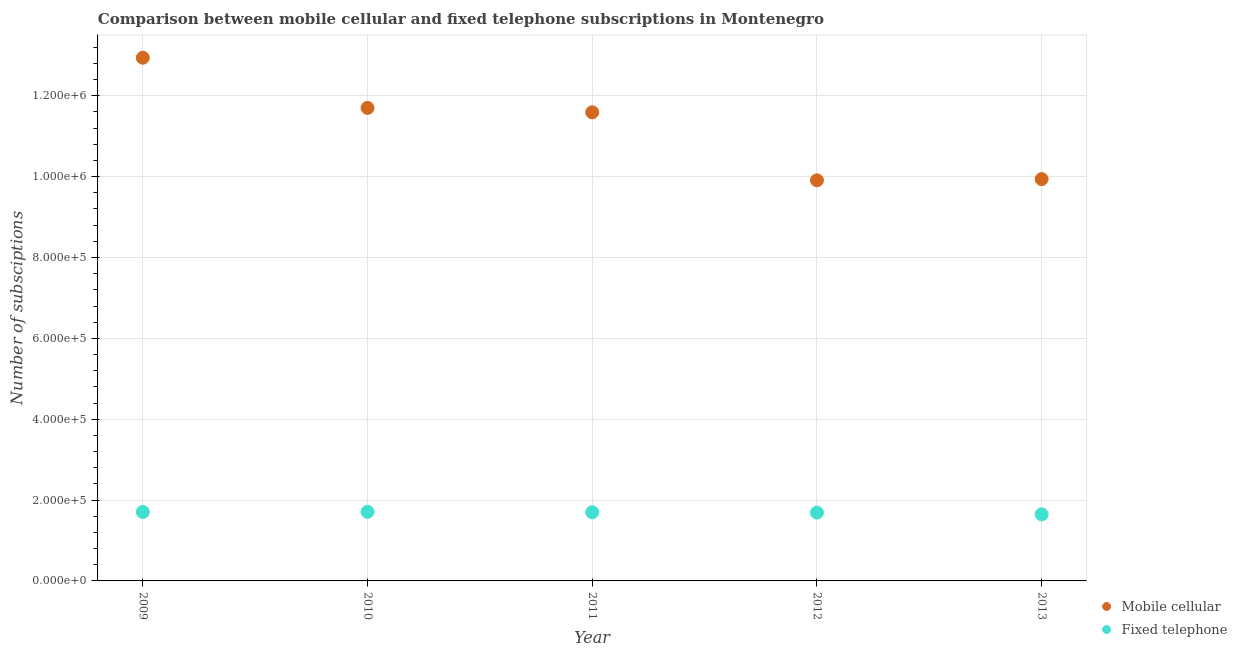Is the number of dotlines equal to the number of legend labels?
Your answer should be compact. Yes. What is the number of fixed telephone subscriptions in 2011?
Keep it short and to the point. 1.70e+05. Across all years, what is the maximum number of mobile cellular subscriptions?
Provide a succinct answer. 1.29e+06. Across all years, what is the minimum number of fixed telephone subscriptions?
Provide a short and direct response. 1.65e+05. In which year was the number of mobile cellular subscriptions maximum?
Keep it short and to the point. 2009. In which year was the number of fixed telephone subscriptions minimum?
Offer a terse response. 2013. What is the total number of fixed telephone subscriptions in the graph?
Your answer should be very brief. 8.45e+05. What is the difference between the number of mobile cellular subscriptions in 2009 and that in 2011?
Give a very brief answer. 1.35e+05. What is the difference between the number of mobile cellular subscriptions in 2011 and the number of fixed telephone subscriptions in 2009?
Offer a very short reply. 9.89e+05. What is the average number of mobile cellular subscriptions per year?
Offer a terse response. 1.12e+06. In the year 2012, what is the difference between the number of mobile cellular subscriptions and number of fixed telephone subscriptions?
Make the answer very short. 8.22e+05. What is the ratio of the number of mobile cellular subscriptions in 2009 to that in 2010?
Offer a terse response. 1.11. Is the number of fixed telephone subscriptions in 2011 less than that in 2012?
Your response must be concise. No. What is the difference between the highest and the second highest number of fixed telephone subscriptions?
Make the answer very short. 303. What is the difference between the highest and the lowest number of mobile cellular subscriptions?
Your response must be concise. 3.03e+05. Does the number of fixed telephone subscriptions monotonically increase over the years?
Your response must be concise. No. Is the number of fixed telephone subscriptions strictly greater than the number of mobile cellular subscriptions over the years?
Offer a terse response. No. How many years are there in the graph?
Offer a very short reply. 5. Are the values on the major ticks of Y-axis written in scientific E-notation?
Your response must be concise. Yes. Where does the legend appear in the graph?
Give a very brief answer. Bottom right. How many legend labels are there?
Give a very brief answer. 2. What is the title of the graph?
Make the answer very short. Comparison between mobile cellular and fixed telephone subscriptions in Montenegro. What is the label or title of the Y-axis?
Make the answer very short. Number of subsciptions. What is the Number of subsciptions of Mobile cellular in 2009?
Your response must be concise. 1.29e+06. What is the Number of subsciptions of Fixed telephone in 2009?
Provide a short and direct response. 1.71e+05. What is the Number of subsciptions in Mobile cellular in 2010?
Offer a terse response. 1.17e+06. What is the Number of subsciptions in Fixed telephone in 2010?
Provide a succinct answer. 1.71e+05. What is the Number of subsciptions of Mobile cellular in 2011?
Offer a terse response. 1.16e+06. What is the Number of subsciptions in Fixed telephone in 2011?
Your answer should be compact. 1.70e+05. What is the Number of subsciptions of Mobile cellular in 2012?
Keep it short and to the point. 9.91e+05. What is the Number of subsciptions of Fixed telephone in 2012?
Offer a very short reply. 1.69e+05. What is the Number of subsciptions in Mobile cellular in 2013?
Make the answer very short. 9.94e+05. What is the Number of subsciptions of Fixed telephone in 2013?
Make the answer very short. 1.65e+05. Across all years, what is the maximum Number of subsciptions in Mobile cellular?
Your answer should be compact. 1.29e+06. Across all years, what is the maximum Number of subsciptions of Fixed telephone?
Offer a very short reply. 1.71e+05. Across all years, what is the minimum Number of subsciptions in Mobile cellular?
Your response must be concise. 9.91e+05. Across all years, what is the minimum Number of subsciptions of Fixed telephone?
Your answer should be very brief. 1.65e+05. What is the total Number of subsciptions in Mobile cellular in the graph?
Your response must be concise. 5.61e+06. What is the total Number of subsciptions in Fixed telephone in the graph?
Keep it short and to the point. 8.45e+05. What is the difference between the Number of subsciptions in Mobile cellular in 2009 and that in 2010?
Provide a succinct answer. 1.24e+05. What is the difference between the Number of subsciptions in Fixed telephone in 2009 and that in 2010?
Your answer should be compact. -303. What is the difference between the Number of subsciptions of Mobile cellular in 2009 and that in 2011?
Keep it short and to the point. 1.35e+05. What is the difference between the Number of subsciptions in Fixed telephone in 2009 and that in 2011?
Keep it short and to the point. 750. What is the difference between the Number of subsciptions of Mobile cellular in 2009 and that in 2012?
Your response must be concise. 3.03e+05. What is the difference between the Number of subsciptions in Fixed telephone in 2009 and that in 2012?
Your answer should be compact. 1521. What is the difference between the Number of subsciptions in Mobile cellular in 2009 and that in 2013?
Give a very brief answer. 3.00e+05. What is the difference between the Number of subsciptions in Fixed telephone in 2009 and that in 2013?
Provide a short and direct response. 5882. What is the difference between the Number of subsciptions in Mobile cellular in 2010 and that in 2011?
Ensure brevity in your answer.  1.09e+04. What is the difference between the Number of subsciptions of Fixed telephone in 2010 and that in 2011?
Offer a terse response. 1053. What is the difference between the Number of subsciptions of Mobile cellular in 2010 and that in 2012?
Your answer should be very brief. 1.79e+05. What is the difference between the Number of subsciptions of Fixed telephone in 2010 and that in 2012?
Ensure brevity in your answer.  1824. What is the difference between the Number of subsciptions of Mobile cellular in 2010 and that in 2013?
Provide a succinct answer. 1.76e+05. What is the difference between the Number of subsciptions in Fixed telephone in 2010 and that in 2013?
Your answer should be very brief. 6185. What is the difference between the Number of subsciptions in Mobile cellular in 2011 and that in 2012?
Make the answer very short. 1.68e+05. What is the difference between the Number of subsciptions in Fixed telephone in 2011 and that in 2012?
Your response must be concise. 771. What is the difference between the Number of subsciptions of Mobile cellular in 2011 and that in 2013?
Keep it short and to the point. 1.65e+05. What is the difference between the Number of subsciptions in Fixed telephone in 2011 and that in 2013?
Your response must be concise. 5132. What is the difference between the Number of subsciptions in Mobile cellular in 2012 and that in 2013?
Make the answer very short. -3033. What is the difference between the Number of subsciptions of Fixed telephone in 2012 and that in 2013?
Your answer should be very brief. 4361. What is the difference between the Number of subsciptions of Mobile cellular in 2009 and the Number of subsciptions of Fixed telephone in 2010?
Keep it short and to the point. 1.12e+06. What is the difference between the Number of subsciptions in Mobile cellular in 2009 and the Number of subsciptions in Fixed telephone in 2011?
Provide a succinct answer. 1.12e+06. What is the difference between the Number of subsciptions in Mobile cellular in 2009 and the Number of subsciptions in Fixed telephone in 2012?
Provide a short and direct response. 1.13e+06. What is the difference between the Number of subsciptions in Mobile cellular in 2009 and the Number of subsciptions in Fixed telephone in 2013?
Give a very brief answer. 1.13e+06. What is the difference between the Number of subsciptions in Mobile cellular in 2010 and the Number of subsciptions in Fixed telephone in 2011?
Make the answer very short. 1.00e+06. What is the difference between the Number of subsciptions of Mobile cellular in 2010 and the Number of subsciptions of Fixed telephone in 2012?
Keep it short and to the point. 1.00e+06. What is the difference between the Number of subsciptions in Mobile cellular in 2010 and the Number of subsciptions in Fixed telephone in 2013?
Your answer should be very brief. 1.01e+06. What is the difference between the Number of subsciptions of Mobile cellular in 2011 and the Number of subsciptions of Fixed telephone in 2012?
Your response must be concise. 9.90e+05. What is the difference between the Number of subsciptions of Mobile cellular in 2011 and the Number of subsciptions of Fixed telephone in 2013?
Your answer should be very brief. 9.94e+05. What is the difference between the Number of subsciptions in Mobile cellular in 2012 and the Number of subsciptions in Fixed telephone in 2013?
Your answer should be very brief. 8.26e+05. What is the average Number of subsciptions of Mobile cellular per year?
Your response must be concise. 1.12e+06. What is the average Number of subsciptions of Fixed telephone per year?
Provide a succinct answer. 1.69e+05. In the year 2009, what is the difference between the Number of subsciptions of Mobile cellular and Number of subsciptions of Fixed telephone?
Provide a short and direct response. 1.12e+06. In the year 2010, what is the difference between the Number of subsciptions of Mobile cellular and Number of subsciptions of Fixed telephone?
Give a very brief answer. 9.99e+05. In the year 2011, what is the difference between the Number of subsciptions in Mobile cellular and Number of subsciptions in Fixed telephone?
Provide a short and direct response. 9.89e+05. In the year 2012, what is the difference between the Number of subsciptions of Mobile cellular and Number of subsciptions of Fixed telephone?
Give a very brief answer. 8.22e+05. In the year 2013, what is the difference between the Number of subsciptions in Mobile cellular and Number of subsciptions in Fixed telephone?
Give a very brief answer. 8.29e+05. What is the ratio of the Number of subsciptions in Mobile cellular in 2009 to that in 2010?
Ensure brevity in your answer.  1.11. What is the ratio of the Number of subsciptions of Mobile cellular in 2009 to that in 2011?
Your response must be concise. 1.12. What is the ratio of the Number of subsciptions in Fixed telephone in 2009 to that in 2011?
Give a very brief answer. 1. What is the ratio of the Number of subsciptions in Mobile cellular in 2009 to that in 2012?
Your response must be concise. 1.31. What is the ratio of the Number of subsciptions of Fixed telephone in 2009 to that in 2012?
Make the answer very short. 1.01. What is the ratio of the Number of subsciptions of Mobile cellular in 2009 to that in 2013?
Make the answer very short. 1.3. What is the ratio of the Number of subsciptions in Fixed telephone in 2009 to that in 2013?
Your response must be concise. 1.04. What is the ratio of the Number of subsciptions of Mobile cellular in 2010 to that in 2011?
Make the answer very short. 1.01. What is the ratio of the Number of subsciptions in Fixed telephone in 2010 to that in 2011?
Provide a succinct answer. 1.01. What is the ratio of the Number of subsciptions in Mobile cellular in 2010 to that in 2012?
Make the answer very short. 1.18. What is the ratio of the Number of subsciptions in Fixed telephone in 2010 to that in 2012?
Provide a succinct answer. 1.01. What is the ratio of the Number of subsciptions of Mobile cellular in 2010 to that in 2013?
Provide a succinct answer. 1.18. What is the ratio of the Number of subsciptions of Fixed telephone in 2010 to that in 2013?
Offer a very short reply. 1.04. What is the ratio of the Number of subsciptions of Mobile cellular in 2011 to that in 2012?
Provide a short and direct response. 1.17. What is the ratio of the Number of subsciptions of Fixed telephone in 2011 to that in 2012?
Give a very brief answer. 1. What is the ratio of the Number of subsciptions of Mobile cellular in 2011 to that in 2013?
Make the answer very short. 1.17. What is the ratio of the Number of subsciptions of Fixed telephone in 2011 to that in 2013?
Your answer should be compact. 1.03. What is the ratio of the Number of subsciptions of Fixed telephone in 2012 to that in 2013?
Provide a short and direct response. 1.03. What is the difference between the highest and the second highest Number of subsciptions in Mobile cellular?
Offer a terse response. 1.24e+05. What is the difference between the highest and the second highest Number of subsciptions of Fixed telephone?
Offer a very short reply. 303. What is the difference between the highest and the lowest Number of subsciptions in Mobile cellular?
Offer a terse response. 3.03e+05. What is the difference between the highest and the lowest Number of subsciptions of Fixed telephone?
Offer a terse response. 6185. 